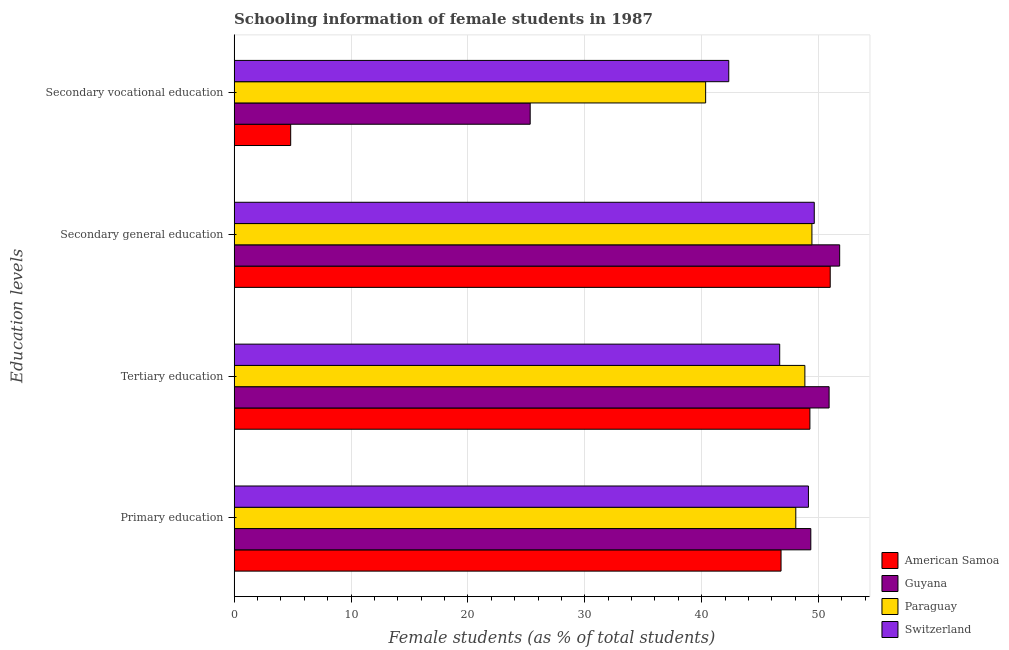Are the number of bars per tick equal to the number of legend labels?
Provide a short and direct response. Yes. Are the number of bars on each tick of the Y-axis equal?
Give a very brief answer. Yes. How many bars are there on the 3rd tick from the top?
Offer a terse response. 4. What is the label of the 4th group of bars from the top?
Your response must be concise. Primary education. What is the percentage of female students in tertiary education in Paraguay?
Give a very brief answer. 48.83. Across all countries, what is the maximum percentage of female students in secondary vocational education?
Offer a terse response. 42.32. Across all countries, what is the minimum percentage of female students in tertiary education?
Offer a terse response. 46.67. In which country was the percentage of female students in secondary vocational education maximum?
Ensure brevity in your answer.  Switzerland. In which country was the percentage of female students in secondary vocational education minimum?
Your answer should be compact. American Samoa. What is the total percentage of female students in secondary vocational education in the graph?
Ensure brevity in your answer.  112.82. What is the difference between the percentage of female students in secondary vocational education in Guyana and that in Switzerland?
Your response must be concise. -16.99. What is the difference between the percentage of female students in secondary vocational education in Paraguay and the percentage of female students in primary education in Switzerland?
Your answer should be very brief. -8.79. What is the average percentage of female students in secondary vocational education per country?
Your answer should be compact. 28.2. What is the difference between the percentage of female students in secondary education and percentage of female students in secondary vocational education in Paraguay?
Your answer should be very brief. 9.09. What is the ratio of the percentage of female students in secondary education in Guyana to that in Switzerland?
Your answer should be compact. 1.04. Is the percentage of female students in tertiary education in Guyana less than that in Switzerland?
Keep it short and to the point. No. What is the difference between the highest and the second highest percentage of female students in secondary vocational education?
Ensure brevity in your answer.  1.98. What is the difference between the highest and the lowest percentage of female students in secondary vocational education?
Ensure brevity in your answer.  37.48. In how many countries, is the percentage of female students in primary education greater than the average percentage of female students in primary education taken over all countries?
Make the answer very short. 2. What does the 1st bar from the top in Secondary vocational education represents?
Make the answer very short. Switzerland. What does the 3rd bar from the bottom in Secondary general education represents?
Provide a short and direct response. Paraguay. How many bars are there?
Offer a terse response. 16. Are all the bars in the graph horizontal?
Keep it short and to the point. Yes. Does the graph contain any zero values?
Provide a succinct answer. No. Does the graph contain grids?
Your answer should be compact. Yes. What is the title of the graph?
Make the answer very short. Schooling information of female students in 1987. Does "Tuvalu" appear as one of the legend labels in the graph?
Provide a short and direct response. No. What is the label or title of the X-axis?
Make the answer very short. Female students (as % of total students). What is the label or title of the Y-axis?
Give a very brief answer. Education levels. What is the Female students (as % of total students) in American Samoa in Primary education?
Provide a short and direct response. 46.79. What is the Female students (as % of total students) in Guyana in Primary education?
Make the answer very short. 49.33. What is the Female students (as % of total students) in Paraguay in Primary education?
Offer a very short reply. 48.05. What is the Female students (as % of total students) of Switzerland in Primary education?
Your response must be concise. 49.13. What is the Female students (as % of total students) in American Samoa in Tertiary education?
Provide a short and direct response. 49.26. What is the Female students (as % of total students) of Guyana in Tertiary education?
Your response must be concise. 50.9. What is the Female students (as % of total students) in Paraguay in Tertiary education?
Make the answer very short. 48.83. What is the Female students (as % of total students) in Switzerland in Tertiary education?
Provide a short and direct response. 46.67. What is the Female students (as % of total students) of American Samoa in Secondary general education?
Your answer should be very brief. 50.99. What is the Female students (as % of total students) in Guyana in Secondary general education?
Provide a succinct answer. 51.8. What is the Female students (as % of total students) in Paraguay in Secondary general education?
Offer a very short reply. 49.43. What is the Female students (as % of total students) in Switzerland in Secondary general education?
Give a very brief answer. 49.63. What is the Female students (as % of total students) of American Samoa in Secondary vocational education?
Your answer should be compact. 4.84. What is the Female students (as % of total students) of Guyana in Secondary vocational education?
Provide a succinct answer. 25.33. What is the Female students (as % of total students) in Paraguay in Secondary vocational education?
Give a very brief answer. 40.34. What is the Female students (as % of total students) in Switzerland in Secondary vocational education?
Your answer should be compact. 42.32. Across all Education levels, what is the maximum Female students (as % of total students) of American Samoa?
Offer a very short reply. 50.99. Across all Education levels, what is the maximum Female students (as % of total students) of Guyana?
Offer a very short reply. 51.8. Across all Education levels, what is the maximum Female students (as % of total students) in Paraguay?
Make the answer very short. 49.43. Across all Education levels, what is the maximum Female students (as % of total students) in Switzerland?
Your response must be concise. 49.63. Across all Education levels, what is the minimum Female students (as % of total students) of American Samoa?
Your response must be concise. 4.84. Across all Education levels, what is the minimum Female students (as % of total students) in Guyana?
Your answer should be compact. 25.33. Across all Education levels, what is the minimum Female students (as % of total students) of Paraguay?
Keep it short and to the point. 40.34. Across all Education levels, what is the minimum Female students (as % of total students) of Switzerland?
Provide a succinct answer. 42.32. What is the total Female students (as % of total students) in American Samoa in the graph?
Provide a succinct answer. 151.88. What is the total Female students (as % of total students) in Guyana in the graph?
Provide a succinct answer. 177.36. What is the total Female students (as % of total students) of Paraguay in the graph?
Ensure brevity in your answer.  186.64. What is the total Female students (as % of total students) of Switzerland in the graph?
Your answer should be compact. 187.75. What is the difference between the Female students (as % of total students) of American Samoa in Primary education and that in Tertiary education?
Offer a very short reply. -2.47. What is the difference between the Female students (as % of total students) in Guyana in Primary education and that in Tertiary education?
Provide a succinct answer. -1.57. What is the difference between the Female students (as % of total students) of Paraguay in Primary education and that in Tertiary education?
Your answer should be very brief. -0.78. What is the difference between the Female students (as % of total students) of Switzerland in Primary education and that in Tertiary education?
Give a very brief answer. 2.46. What is the difference between the Female students (as % of total students) in American Samoa in Primary education and that in Secondary general education?
Offer a terse response. -4.21. What is the difference between the Female students (as % of total students) in Guyana in Primary education and that in Secondary general education?
Offer a terse response. -2.47. What is the difference between the Female students (as % of total students) in Paraguay in Primary education and that in Secondary general education?
Your answer should be very brief. -1.38. What is the difference between the Female students (as % of total students) of Switzerland in Primary education and that in Secondary general education?
Offer a terse response. -0.5. What is the difference between the Female students (as % of total students) in American Samoa in Primary education and that in Secondary vocational education?
Your response must be concise. 41.95. What is the difference between the Female students (as % of total students) in Guyana in Primary education and that in Secondary vocational education?
Offer a very short reply. 24.01. What is the difference between the Female students (as % of total students) in Paraguay in Primary education and that in Secondary vocational education?
Ensure brevity in your answer.  7.71. What is the difference between the Female students (as % of total students) in Switzerland in Primary education and that in Secondary vocational education?
Your response must be concise. 6.82. What is the difference between the Female students (as % of total students) of American Samoa in Tertiary education and that in Secondary general education?
Your response must be concise. -1.74. What is the difference between the Female students (as % of total students) of Guyana in Tertiary education and that in Secondary general education?
Your response must be concise. -0.9. What is the difference between the Female students (as % of total students) of Paraguay in Tertiary education and that in Secondary general education?
Provide a short and direct response. -0.6. What is the difference between the Female students (as % of total students) in Switzerland in Tertiary education and that in Secondary general education?
Your answer should be compact. -2.96. What is the difference between the Female students (as % of total students) of American Samoa in Tertiary education and that in Secondary vocational education?
Offer a terse response. 44.42. What is the difference between the Female students (as % of total students) of Guyana in Tertiary education and that in Secondary vocational education?
Your answer should be very brief. 25.57. What is the difference between the Female students (as % of total students) of Paraguay in Tertiary education and that in Secondary vocational education?
Give a very brief answer. 8.49. What is the difference between the Female students (as % of total students) of Switzerland in Tertiary education and that in Secondary vocational education?
Offer a terse response. 4.36. What is the difference between the Female students (as % of total students) of American Samoa in Secondary general education and that in Secondary vocational education?
Offer a very short reply. 46.15. What is the difference between the Female students (as % of total students) in Guyana in Secondary general education and that in Secondary vocational education?
Your answer should be very brief. 26.47. What is the difference between the Female students (as % of total students) in Paraguay in Secondary general education and that in Secondary vocational education?
Your answer should be compact. 9.09. What is the difference between the Female students (as % of total students) of Switzerland in Secondary general education and that in Secondary vocational education?
Your answer should be compact. 7.31. What is the difference between the Female students (as % of total students) of American Samoa in Primary education and the Female students (as % of total students) of Guyana in Tertiary education?
Offer a terse response. -4.11. What is the difference between the Female students (as % of total students) in American Samoa in Primary education and the Female students (as % of total students) in Paraguay in Tertiary education?
Offer a very short reply. -2.04. What is the difference between the Female students (as % of total students) of American Samoa in Primary education and the Female students (as % of total students) of Switzerland in Tertiary education?
Offer a very short reply. 0.12. What is the difference between the Female students (as % of total students) of Guyana in Primary education and the Female students (as % of total students) of Paraguay in Tertiary education?
Provide a succinct answer. 0.51. What is the difference between the Female students (as % of total students) of Guyana in Primary education and the Female students (as % of total students) of Switzerland in Tertiary education?
Ensure brevity in your answer.  2.66. What is the difference between the Female students (as % of total students) of Paraguay in Primary education and the Female students (as % of total students) of Switzerland in Tertiary education?
Make the answer very short. 1.38. What is the difference between the Female students (as % of total students) in American Samoa in Primary education and the Female students (as % of total students) in Guyana in Secondary general education?
Provide a short and direct response. -5.01. What is the difference between the Female students (as % of total students) of American Samoa in Primary education and the Female students (as % of total students) of Paraguay in Secondary general education?
Your answer should be very brief. -2.64. What is the difference between the Female students (as % of total students) in American Samoa in Primary education and the Female students (as % of total students) in Switzerland in Secondary general education?
Ensure brevity in your answer.  -2.84. What is the difference between the Female students (as % of total students) in Guyana in Primary education and the Female students (as % of total students) in Paraguay in Secondary general education?
Offer a very short reply. -0.09. What is the difference between the Female students (as % of total students) in Guyana in Primary education and the Female students (as % of total students) in Switzerland in Secondary general education?
Your response must be concise. -0.3. What is the difference between the Female students (as % of total students) of Paraguay in Primary education and the Female students (as % of total students) of Switzerland in Secondary general education?
Provide a succinct answer. -1.58. What is the difference between the Female students (as % of total students) of American Samoa in Primary education and the Female students (as % of total students) of Guyana in Secondary vocational education?
Offer a very short reply. 21.46. What is the difference between the Female students (as % of total students) in American Samoa in Primary education and the Female students (as % of total students) in Paraguay in Secondary vocational education?
Keep it short and to the point. 6.45. What is the difference between the Female students (as % of total students) in American Samoa in Primary education and the Female students (as % of total students) in Switzerland in Secondary vocational education?
Provide a short and direct response. 4.47. What is the difference between the Female students (as % of total students) of Guyana in Primary education and the Female students (as % of total students) of Paraguay in Secondary vocational education?
Your answer should be very brief. 9. What is the difference between the Female students (as % of total students) of Guyana in Primary education and the Female students (as % of total students) of Switzerland in Secondary vocational education?
Make the answer very short. 7.02. What is the difference between the Female students (as % of total students) in Paraguay in Primary education and the Female students (as % of total students) in Switzerland in Secondary vocational education?
Your answer should be very brief. 5.73. What is the difference between the Female students (as % of total students) of American Samoa in Tertiary education and the Female students (as % of total students) of Guyana in Secondary general education?
Offer a terse response. -2.55. What is the difference between the Female students (as % of total students) in American Samoa in Tertiary education and the Female students (as % of total students) in Paraguay in Secondary general education?
Make the answer very short. -0.17. What is the difference between the Female students (as % of total students) of American Samoa in Tertiary education and the Female students (as % of total students) of Switzerland in Secondary general education?
Provide a succinct answer. -0.37. What is the difference between the Female students (as % of total students) in Guyana in Tertiary education and the Female students (as % of total students) in Paraguay in Secondary general education?
Your answer should be very brief. 1.47. What is the difference between the Female students (as % of total students) of Guyana in Tertiary education and the Female students (as % of total students) of Switzerland in Secondary general education?
Your response must be concise. 1.27. What is the difference between the Female students (as % of total students) in Paraguay in Tertiary education and the Female students (as % of total students) in Switzerland in Secondary general education?
Ensure brevity in your answer.  -0.8. What is the difference between the Female students (as % of total students) of American Samoa in Tertiary education and the Female students (as % of total students) of Guyana in Secondary vocational education?
Make the answer very short. 23.93. What is the difference between the Female students (as % of total students) of American Samoa in Tertiary education and the Female students (as % of total students) of Paraguay in Secondary vocational education?
Provide a short and direct response. 8.92. What is the difference between the Female students (as % of total students) in American Samoa in Tertiary education and the Female students (as % of total students) in Switzerland in Secondary vocational education?
Provide a short and direct response. 6.94. What is the difference between the Female students (as % of total students) in Guyana in Tertiary education and the Female students (as % of total students) in Paraguay in Secondary vocational education?
Provide a succinct answer. 10.56. What is the difference between the Female students (as % of total students) in Guyana in Tertiary education and the Female students (as % of total students) in Switzerland in Secondary vocational education?
Ensure brevity in your answer.  8.58. What is the difference between the Female students (as % of total students) in Paraguay in Tertiary education and the Female students (as % of total students) in Switzerland in Secondary vocational education?
Your answer should be compact. 6.51. What is the difference between the Female students (as % of total students) of American Samoa in Secondary general education and the Female students (as % of total students) of Guyana in Secondary vocational education?
Offer a very short reply. 25.67. What is the difference between the Female students (as % of total students) of American Samoa in Secondary general education and the Female students (as % of total students) of Paraguay in Secondary vocational education?
Your response must be concise. 10.66. What is the difference between the Female students (as % of total students) of American Samoa in Secondary general education and the Female students (as % of total students) of Switzerland in Secondary vocational education?
Give a very brief answer. 8.68. What is the difference between the Female students (as % of total students) of Guyana in Secondary general education and the Female students (as % of total students) of Paraguay in Secondary vocational education?
Make the answer very short. 11.47. What is the difference between the Female students (as % of total students) of Guyana in Secondary general education and the Female students (as % of total students) of Switzerland in Secondary vocational education?
Keep it short and to the point. 9.49. What is the difference between the Female students (as % of total students) in Paraguay in Secondary general education and the Female students (as % of total students) in Switzerland in Secondary vocational education?
Provide a short and direct response. 7.11. What is the average Female students (as % of total students) in American Samoa per Education levels?
Ensure brevity in your answer.  37.97. What is the average Female students (as % of total students) in Guyana per Education levels?
Ensure brevity in your answer.  44.34. What is the average Female students (as % of total students) in Paraguay per Education levels?
Your answer should be very brief. 46.66. What is the average Female students (as % of total students) in Switzerland per Education levels?
Your response must be concise. 46.94. What is the difference between the Female students (as % of total students) in American Samoa and Female students (as % of total students) in Guyana in Primary education?
Your response must be concise. -2.55. What is the difference between the Female students (as % of total students) of American Samoa and Female students (as % of total students) of Paraguay in Primary education?
Offer a very short reply. -1.26. What is the difference between the Female students (as % of total students) of American Samoa and Female students (as % of total students) of Switzerland in Primary education?
Keep it short and to the point. -2.34. What is the difference between the Female students (as % of total students) in Guyana and Female students (as % of total students) in Paraguay in Primary education?
Offer a very short reply. 1.28. What is the difference between the Female students (as % of total students) of Guyana and Female students (as % of total students) of Switzerland in Primary education?
Offer a very short reply. 0.2. What is the difference between the Female students (as % of total students) in Paraguay and Female students (as % of total students) in Switzerland in Primary education?
Give a very brief answer. -1.08. What is the difference between the Female students (as % of total students) in American Samoa and Female students (as % of total students) in Guyana in Tertiary education?
Your response must be concise. -1.64. What is the difference between the Female students (as % of total students) in American Samoa and Female students (as % of total students) in Paraguay in Tertiary education?
Offer a terse response. 0.43. What is the difference between the Female students (as % of total students) in American Samoa and Female students (as % of total students) in Switzerland in Tertiary education?
Your answer should be very brief. 2.58. What is the difference between the Female students (as % of total students) of Guyana and Female students (as % of total students) of Paraguay in Tertiary education?
Make the answer very short. 2.07. What is the difference between the Female students (as % of total students) in Guyana and Female students (as % of total students) in Switzerland in Tertiary education?
Give a very brief answer. 4.23. What is the difference between the Female students (as % of total students) in Paraguay and Female students (as % of total students) in Switzerland in Tertiary education?
Make the answer very short. 2.15. What is the difference between the Female students (as % of total students) of American Samoa and Female students (as % of total students) of Guyana in Secondary general education?
Your answer should be very brief. -0.81. What is the difference between the Female students (as % of total students) in American Samoa and Female students (as % of total students) in Paraguay in Secondary general education?
Make the answer very short. 1.57. What is the difference between the Female students (as % of total students) of American Samoa and Female students (as % of total students) of Switzerland in Secondary general education?
Offer a terse response. 1.36. What is the difference between the Female students (as % of total students) of Guyana and Female students (as % of total students) of Paraguay in Secondary general education?
Give a very brief answer. 2.37. What is the difference between the Female students (as % of total students) in Guyana and Female students (as % of total students) in Switzerland in Secondary general education?
Your answer should be very brief. 2.17. What is the difference between the Female students (as % of total students) in Paraguay and Female students (as % of total students) in Switzerland in Secondary general education?
Your answer should be very brief. -0.2. What is the difference between the Female students (as % of total students) of American Samoa and Female students (as % of total students) of Guyana in Secondary vocational education?
Your answer should be compact. -20.49. What is the difference between the Female students (as % of total students) of American Samoa and Female students (as % of total students) of Paraguay in Secondary vocational education?
Keep it short and to the point. -35.5. What is the difference between the Female students (as % of total students) in American Samoa and Female students (as % of total students) in Switzerland in Secondary vocational education?
Your response must be concise. -37.48. What is the difference between the Female students (as % of total students) of Guyana and Female students (as % of total students) of Paraguay in Secondary vocational education?
Give a very brief answer. -15.01. What is the difference between the Female students (as % of total students) of Guyana and Female students (as % of total students) of Switzerland in Secondary vocational education?
Provide a succinct answer. -16.99. What is the difference between the Female students (as % of total students) in Paraguay and Female students (as % of total students) in Switzerland in Secondary vocational education?
Offer a terse response. -1.98. What is the ratio of the Female students (as % of total students) in American Samoa in Primary education to that in Tertiary education?
Offer a terse response. 0.95. What is the ratio of the Female students (as % of total students) in Guyana in Primary education to that in Tertiary education?
Your answer should be compact. 0.97. What is the ratio of the Female students (as % of total students) in Paraguay in Primary education to that in Tertiary education?
Provide a short and direct response. 0.98. What is the ratio of the Female students (as % of total students) in Switzerland in Primary education to that in Tertiary education?
Your answer should be compact. 1.05. What is the ratio of the Female students (as % of total students) of American Samoa in Primary education to that in Secondary general education?
Your answer should be compact. 0.92. What is the ratio of the Female students (as % of total students) of Guyana in Primary education to that in Secondary general education?
Keep it short and to the point. 0.95. What is the ratio of the Female students (as % of total students) of Paraguay in Primary education to that in Secondary general education?
Give a very brief answer. 0.97. What is the ratio of the Female students (as % of total students) of American Samoa in Primary education to that in Secondary vocational education?
Provide a succinct answer. 9.67. What is the ratio of the Female students (as % of total students) in Guyana in Primary education to that in Secondary vocational education?
Your answer should be very brief. 1.95. What is the ratio of the Female students (as % of total students) of Paraguay in Primary education to that in Secondary vocational education?
Your response must be concise. 1.19. What is the ratio of the Female students (as % of total students) of Switzerland in Primary education to that in Secondary vocational education?
Offer a terse response. 1.16. What is the ratio of the Female students (as % of total students) of American Samoa in Tertiary education to that in Secondary general education?
Make the answer very short. 0.97. What is the ratio of the Female students (as % of total students) in Guyana in Tertiary education to that in Secondary general education?
Provide a succinct answer. 0.98. What is the ratio of the Female students (as % of total students) in Paraguay in Tertiary education to that in Secondary general education?
Your answer should be very brief. 0.99. What is the ratio of the Female students (as % of total students) in Switzerland in Tertiary education to that in Secondary general education?
Offer a terse response. 0.94. What is the ratio of the Female students (as % of total students) of American Samoa in Tertiary education to that in Secondary vocational education?
Your answer should be compact. 10.18. What is the ratio of the Female students (as % of total students) in Guyana in Tertiary education to that in Secondary vocational education?
Your answer should be very brief. 2.01. What is the ratio of the Female students (as % of total students) in Paraguay in Tertiary education to that in Secondary vocational education?
Offer a terse response. 1.21. What is the ratio of the Female students (as % of total students) of Switzerland in Tertiary education to that in Secondary vocational education?
Offer a very short reply. 1.1. What is the ratio of the Female students (as % of total students) in American Samoa in Secondary general education to that in Secondary vocational education?
Offer a terse response. 10.54. What is the ratio of the Female students (as % of total students) in Guyana in Secondary general education to that in Secondary vocational education?
Provide a succinct answer. 2.05. What is the ratio of the Female students (as % of total students) of Paraguay in Secondary general education to that in Secondary vocational education?
Offer a terse response. 1.23. What is the ratio of the Female students (as % of total students) of Switzerland in Secondary general education to that in Secondary vocational education?
Provide a succinct answer. 1.17. What is the difference between the highest and the second highest Female students (as % of total students) in American Samoa?
Offer a terse response. 1.74. What is the difference between the highest and the second highest Female students (as % of total students) in Guyana?
Provide a succinct answer. 0.9. What is the difference between the highest and the second highest Female students (as % of total students) in Paraguay?
Provide a succinct answer. 0.6. What is the difference between the highest and the second highest Female students (as % of total students) in Switzerland?
Give a very brief answer. 0.5. What is the difference between the highest and the lowest Female students (as % of total students) in American Samoa?
Make the answer very short. 46.15. What is the difference between the highest and the lowest Female students (as % of total students) of Guyana?
Offer a terse response. 26.47. What is the difference between the highest and the lowest Female students (as % of total students) of Paraguay?
Provide a short and direct response. 9.09. What is the difference between the highest and the lowest Female students (as % of total students) in Switzerland?
Provide a short and direct response. 7.31. 